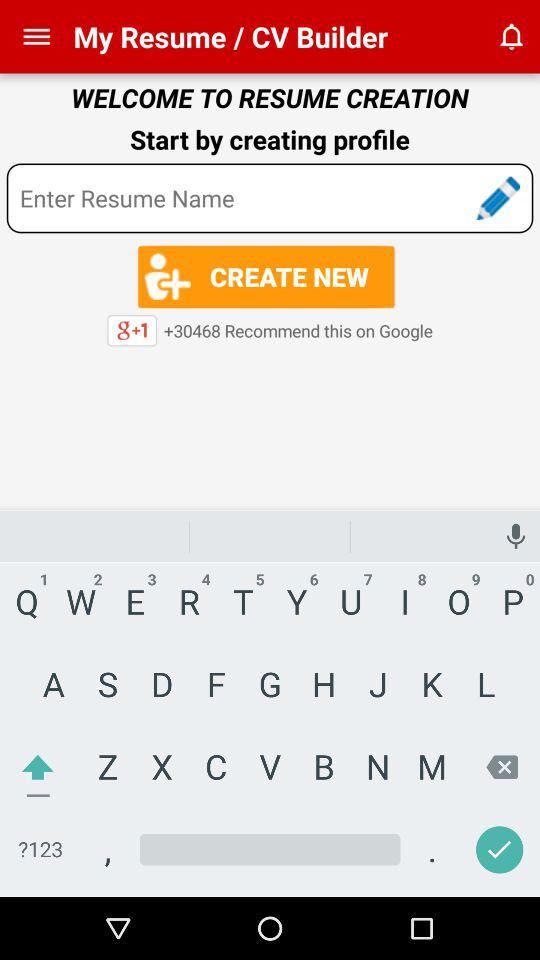What is the name of the resume?
When the provided information is insufficient, respond with <no answer>. <no answer> 